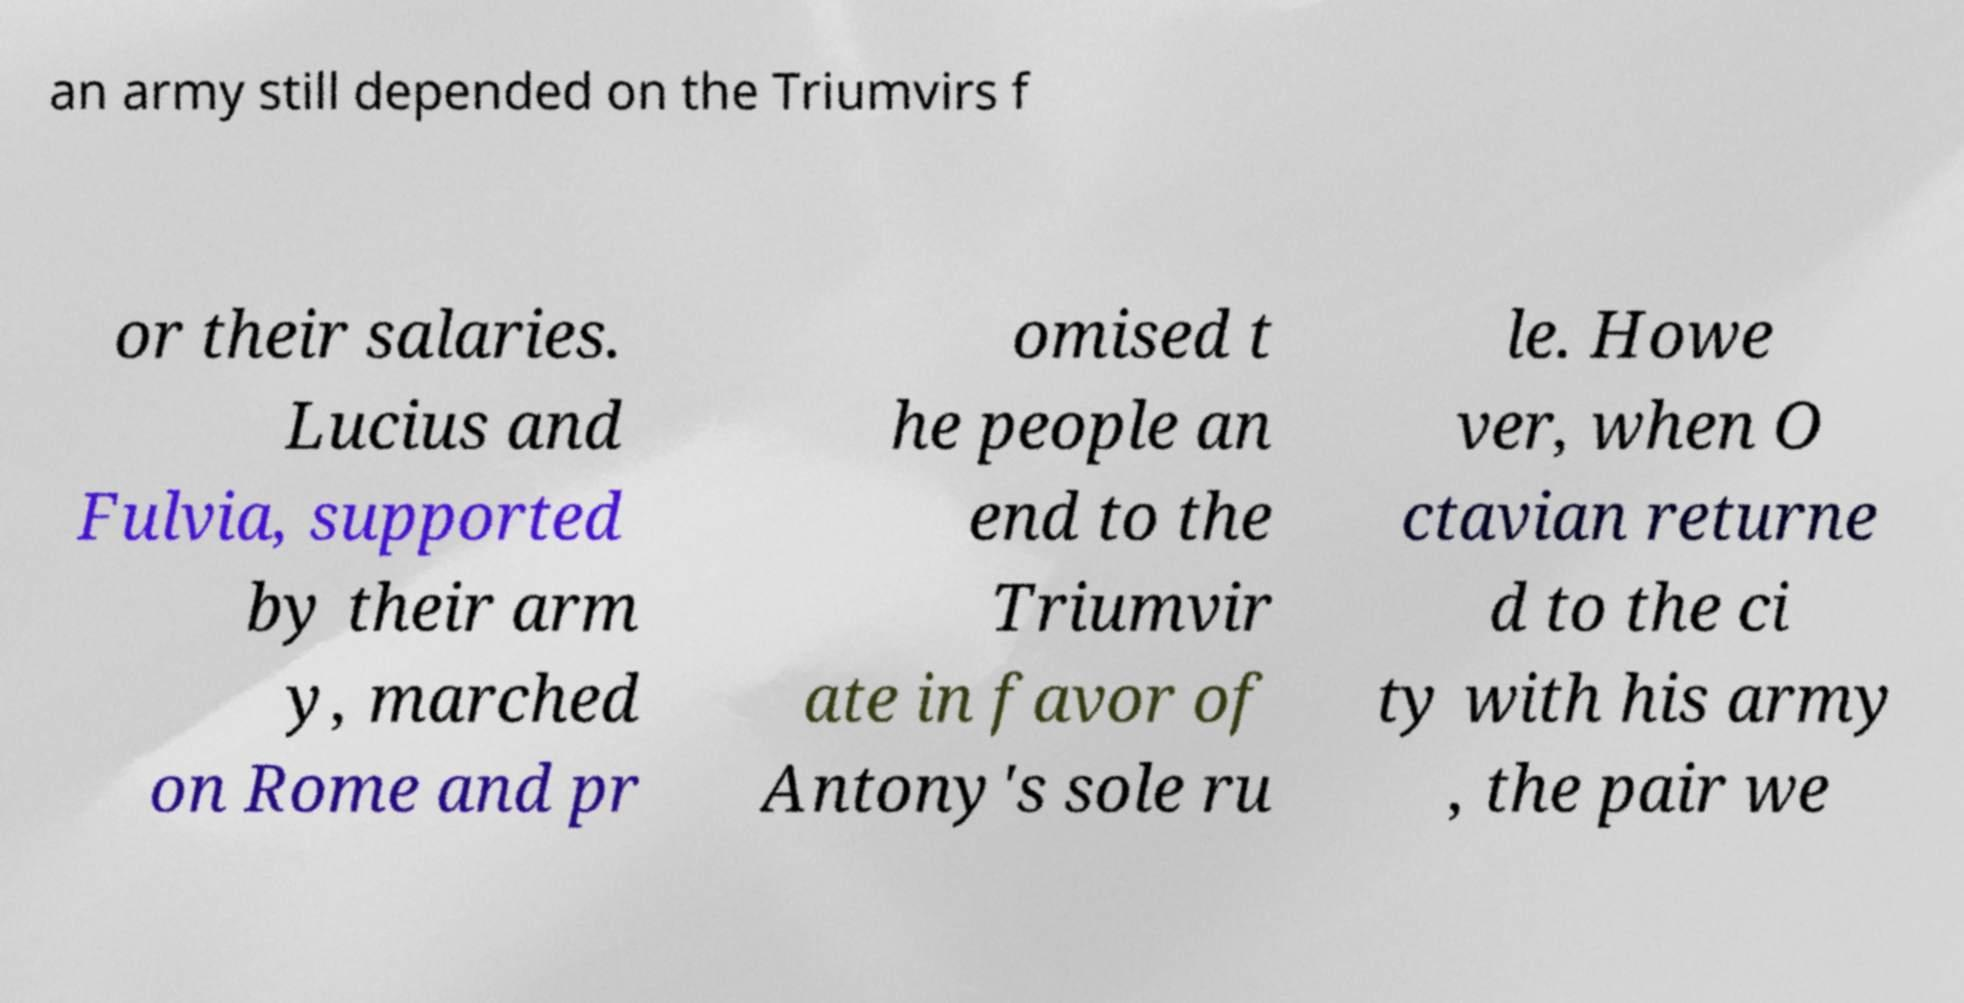Please read and relay the text visible in this image. What does it say? an army still depended on the Triumvirs f or their salaries. Lucius and Fulvia, supported by their arm y, marched on Rome and pr omised t he people an end to the Triumvir ate in favor of Antony's sole ru le. Howe ver, when O ctavian returne d to the ci ty with his army , the pair we 